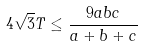Convert formula to latex. <formula><loc_0><loc_0><loc_500><loc_500>4 \sqrt { 3 } T \leq \frac { 9 a b c } { a + b + c }</formula> 